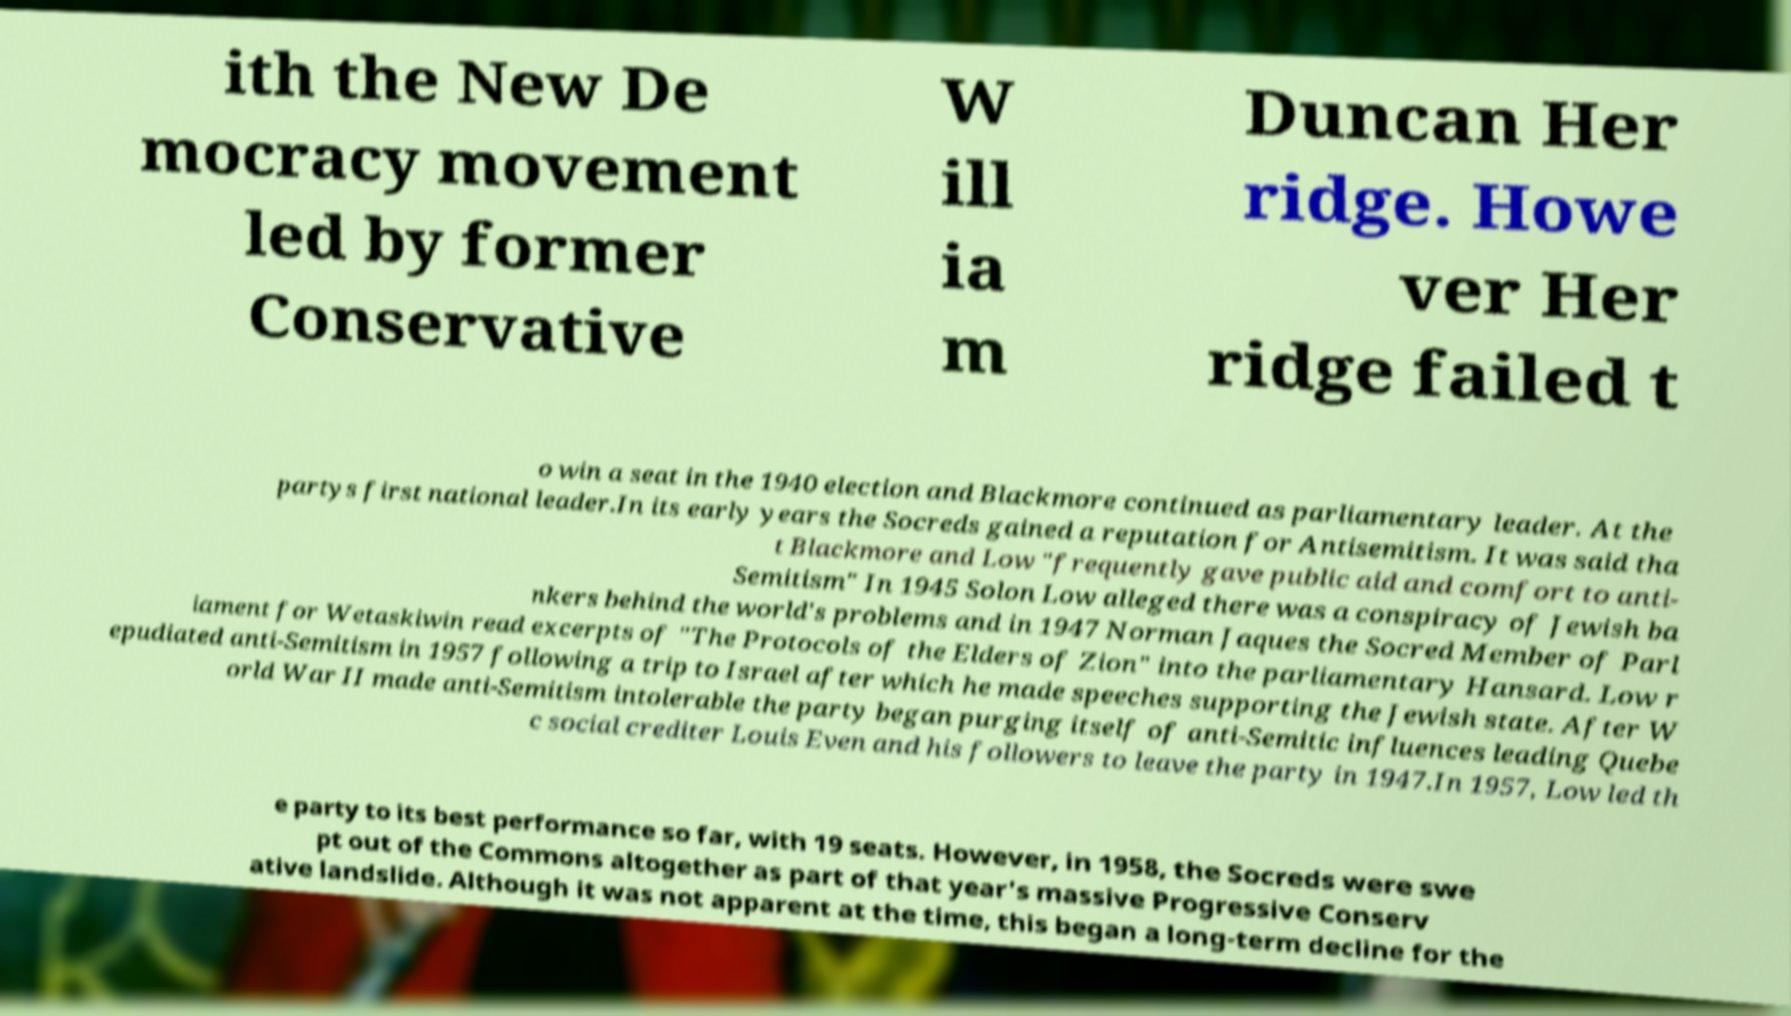Please identify and transcribe the text found in this image. ith the New De mocracy movement led by former Conservative W ill ia m Duncan Her ridge. Howe ver Her ridge failed t o win a seat in the 1940 election and Blackmore continued as parliamentary leader. At the partys first national leader.In its early years the Socreds gained a reputation for Antisemitism. It was said tha t Blackmore and Low "frequently gave public aid and comfort to anti- Semitism" In 1945 Solon Low alleged there was a conspiracy of Jewish ba nkers behind the world's problems and in 1947 Norman Jaques the Socred Member of Parl iament for Wetaskiwin read excerpts of "The Protocols of the Elders of Zion" into the parliamentary Hansard. Low r epudiated anti-Semitism in 1957 following a trip to Israel after which he made speeches supporting the Jewish state. After W orld War II made anti-Semitism intolerable the party began purging itself of anti-Semitic influences leading Quebe c social crediter Louis Even and his followers to leave the party in 1947.In 1957, Low led th e party to its best performance so far, with 19 seats. However, in 1958, the Socreds were swe pt out of the Commons altogether as part of that year's massive Progressive Conserv ative landslide. Although it was not apparent at the time, this began a long-term decline for the 